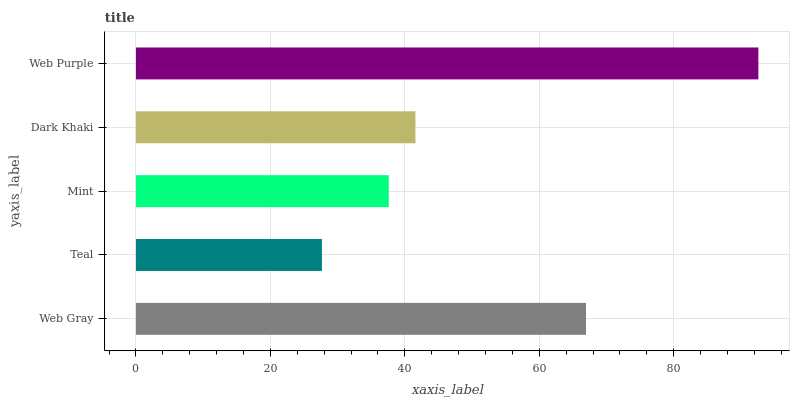Is Teal the minimum?
Answer yes or no. Yes. Is Web Purple the maximum?
Answer yes or no. Yes. Is Mint the minimum?
Answer yes or no. No. Is Mint the maximum?
Answer yes or no. No. Is Mint greater than Teal?
Answer yes or no. Yes. Is Teal less than Mint?
Answer yes or no. Yes. Is Teal greater than Mint?
Answer yes or no. No. Is Mint less than Teal?
Answer yes or no. No. Is Dark Khaki the high median?
Answer yes or no. Yes. Is Dark Khaki the low median?
Answer yes or no. Yes. Is Web Gray the high median?
Answer yes or no. No. Is Web Gray the low median?
Answer yes or no. No. 